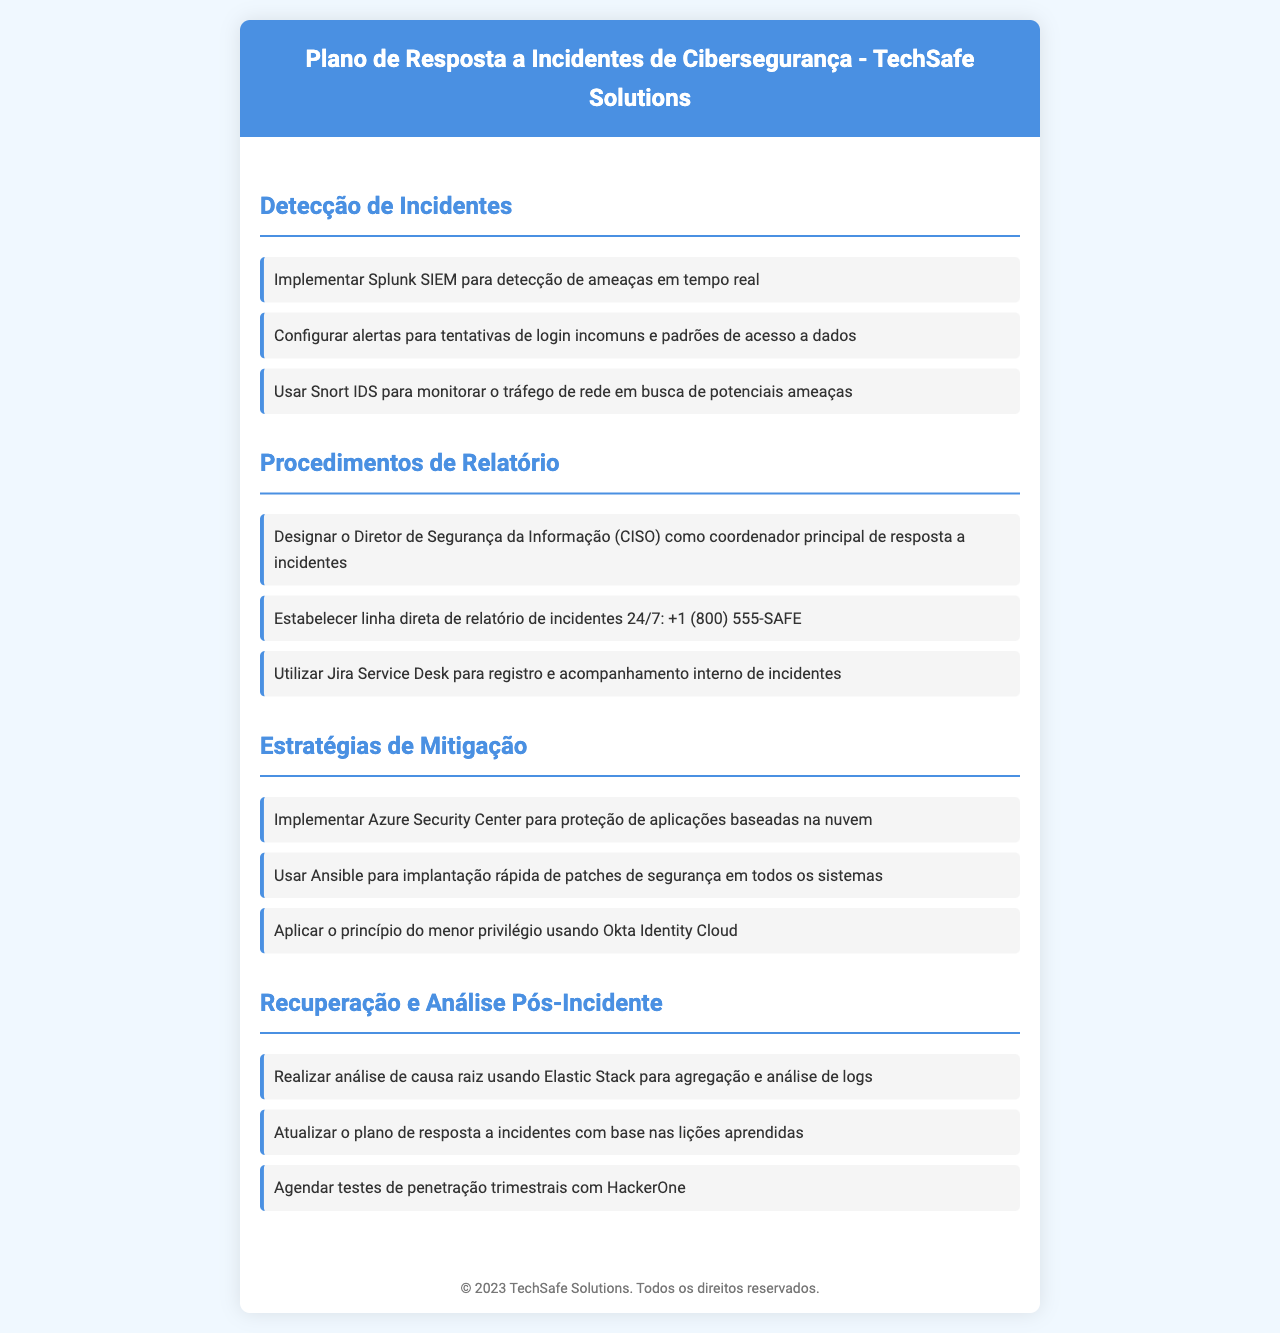qual é o título do documento? O título do documento é exibido no cabeçalho e refere-se ao plano de resposta a incidentes de cibersegurança da empresa.
Answer: Plano de Resposta a Incidentes de Cibersegurança - TechSafe Solutions quem é o coordenador principal de resposta a incidentes? A designação do coordenador principal de resposta a incidentes está claramente mencionada na seção de Procedimentos de Relatório.
Answer: Diretor de Segurança da Informação (CISO) qual ferramenta é utilizada para a análise de causa raiz? A ferramenta específica para a análise de causa raiz é mencionada na seção de Recuperação e Análise Pós-Incidente.
Answer: Elastic Stack que tipo de segurança deve ser aplicada às aplicações baseadas na nuvem? A medida de segurança a ser implementada para aplicações na nuvem é detalhada na seção de Estratégias de Mitigação.
Answer: Azure Security Center quantos testes de penetração devem ser agendados anualmente? O documento menciona a frequência dos testes de penetração na seção de Recuperação e Análise Pós-Incidente.
Answer: trimestrais como os incidentes devem ser registrados internamente? O método para registro e acompanhamento interno é descrito na seção de Procedimentos de Relatório.
Answer: Jira Service Desk qual é o número da linha direta de relatório de incidentes? O número da linha direta para relatar incidentes está indicado na seção de Procedimentos de Relatório.
Answer: +1 (800) 555-SAFE qual princípio deve ser aplicado em relação ao acesso? O princípio mencionado para limitar o acesso é discutido na seção de Estratégias de Mitigação.
Answer: menor privilégio 